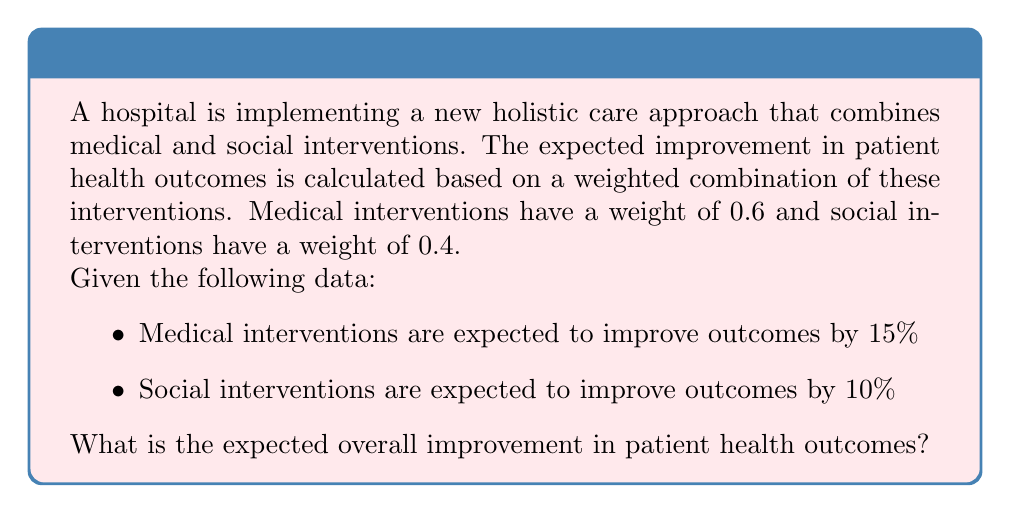Solve this math problem. To solve this problem, we'll use the concept of weighted average and follow these steps:

1. Identify the weights and individual improvement percentages:
   - Medical interventions: weight = 0.6, improvement = 15%
   - Social interventions: weight = 0.4, improvement = 10%

2. Calculate the weighted contribution of each intervention:
   - Medical contribution = 0.6 × 15% = 9%
   - Social contribution = 0.4 × 10% = 4%

3. Sum the weighted contributions to get the overall expected improvement:

   $$\text{Expected Improvement} = (\text{Weight}_{\text{medical}} \times \text{Improvement}_{\text{medical}}) + (\text{Weight}_{\text{social}} \times \text{Improvement}_{\text{social}})$$

   $$\text{Expected Improvement} = (0.6 \times 15\%) + (0.4 \times 10\%)$$
   $$\text{Expected Improvement} = 9\% + 4\% = 13\%$$

Therefore, the expected overall improvement in patient health outcomes is 13%.
Answer: 13% 